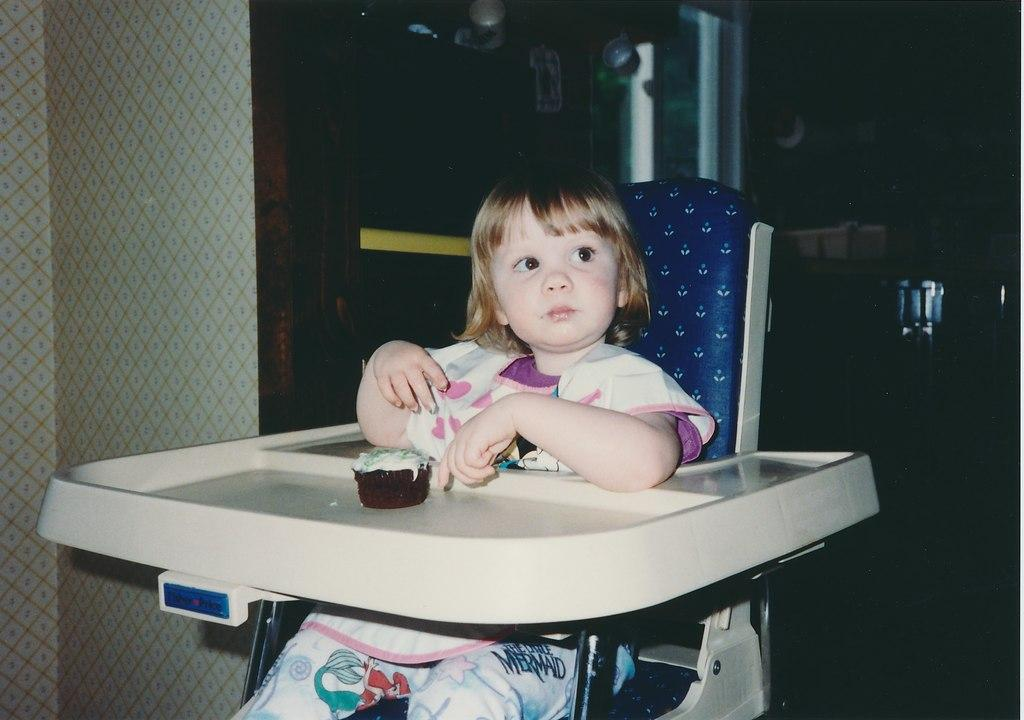What is the kid in the image doing? The kid is sitting in a chair and eating a cupcake. Can you describe the chair the kid is sitting on? The provided facts do not give a detailed description of the chair. What can be seen in the background of the image? There are many objects visible in the background. What is located on the left side of the image? There is a well on the left side of the image. How many cherries are on the giraffe in the image? There is no giraffe or cherry present in the image. What type of boundary can be seen surrounding the well in the image? The provided facts do not mention any boundary around the well. 